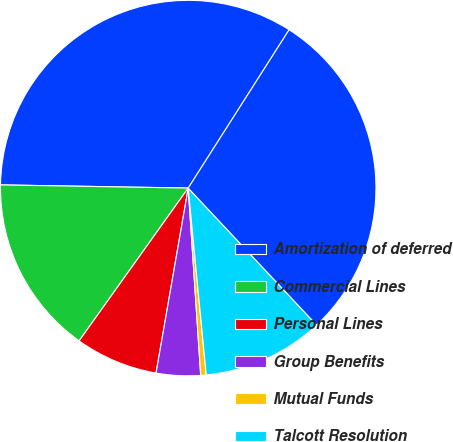<chart> <loc_0><loc_0><loc_500><loc_500><pie_chart><fcel>Amortization of deferred<fcel>Commercial Lines<fcel>Personal Lines<fcel>Group Benefits<fcel>Mutual Funds<fcel>Talcott Resolution<fcel>Total amortization of deferred<nl><fcel>33.76%<fcel>15.4%<fcel>7.13%<fcel>3.8%<fcel>0.47%<fcel>10.46%<fcel>28.98%<nl></chart> 